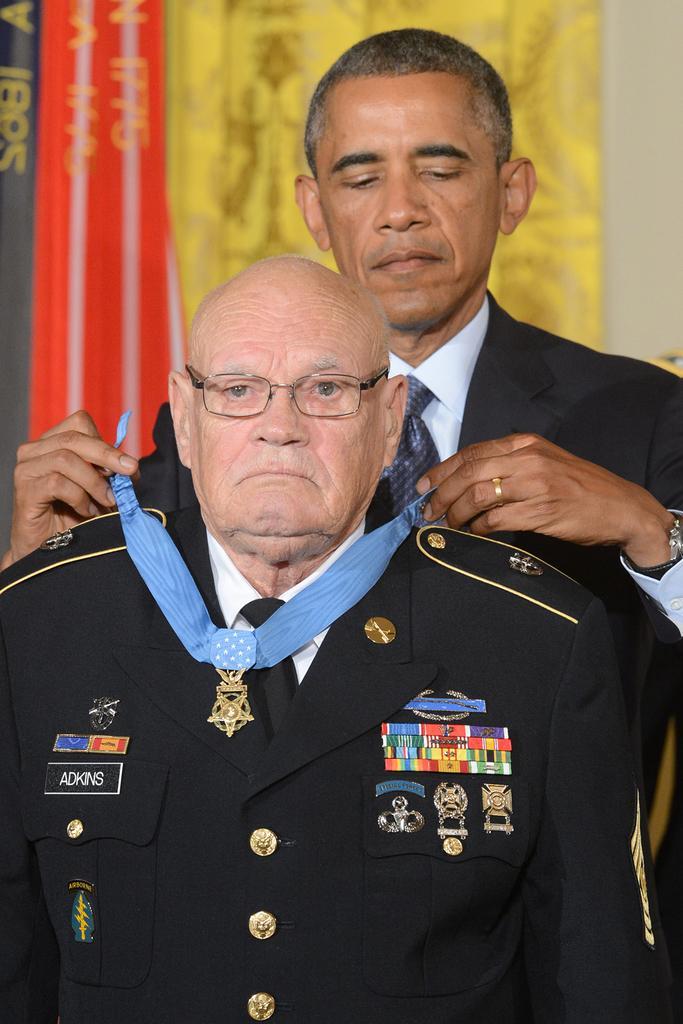Please provide a concise description of this image. In the foreground of this image, there is a man standing in black coat, behind him there is another person putting a medal to the person in front of him. In the background, there are flags and the wall. 